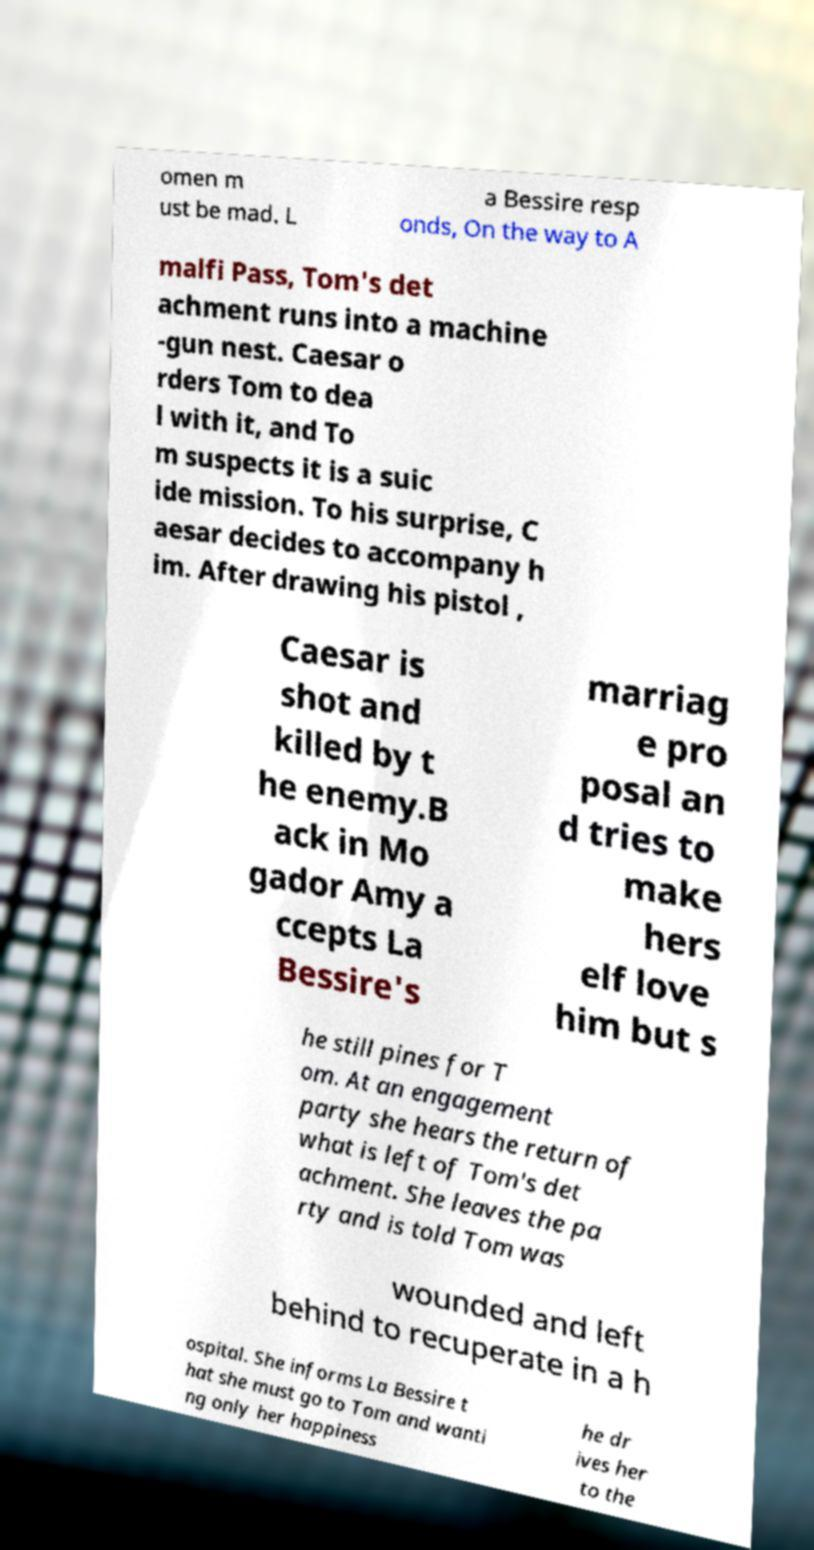I need the written content from this picture converted into text. Can you do that? omen m ust be mad. L a Bessire resp onds, On the way to A malfi Pass, Tom's det achment runs into a machine -gun nest. Caesar o rders Tom to dea l with it, and To m suspects it is a suic ide mission. To his surprise, C aesar decides to accompany h im. After drawing his pistol , Caesar is shot and killed by t he enemy.B ack in Mo gador Amy a ccepts La Bessire's marriag e pro posal an d tries to make hers elf love him but s he still pines for T om. At an engagement party she hears the return of what is left of Tom's det achment. She leaves the pa rty and is told Tom was wounded and left behind to recuperate in a h ospital. She informs La Bessire t hat she must go to Tom and wanti ng only her happiness he dr ives her to the 